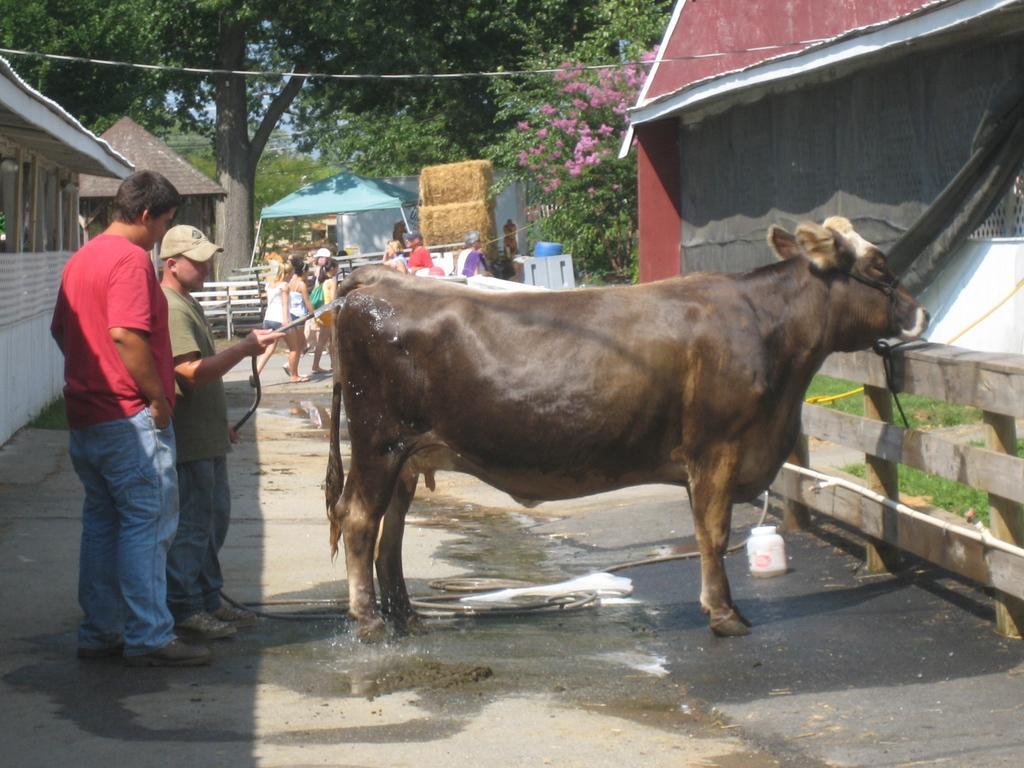Describe this image in one or two sentences. This image consists of a cow. At the bottom, there is a road. On the left, we can see two persons. The man wearing cap is holding a water pipe. In the background, we can see few persons along with the trees and tents. On the left, there are huts. 